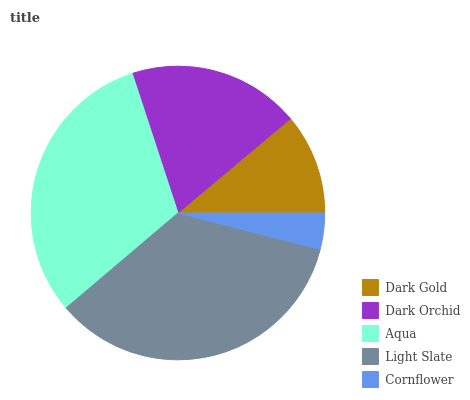Is Cornflower the minimum?
Answer yes or no. Yes. Is Light Slate the maximum?
Answer yes or no. Yes. Is Dark Orchid the minimum?
Answer yes or no. No. Is Dark Orchid the maximum?
Answer yes or no. No. Is Dark Orchid greater than Dark Gold?
Answer yes or no. Yes. Is Dark Gold less than Dark Orchid?
Answer yes or no. Yes. Is Dark Gold greater than Dark Orchid?
Answer yes or no. No. Is Dark Orchid less than Dark Gold?
Answer yes or no. No. Is Dark Orchid the high median?
Answer yes or no. Yes. Is Dark Orchid the low median?
Answer yes or no. Yes. Is Dark Gold the high median?
Answer yes or no. No. Is Cornflower the low median?
Answer yes or no. No. 